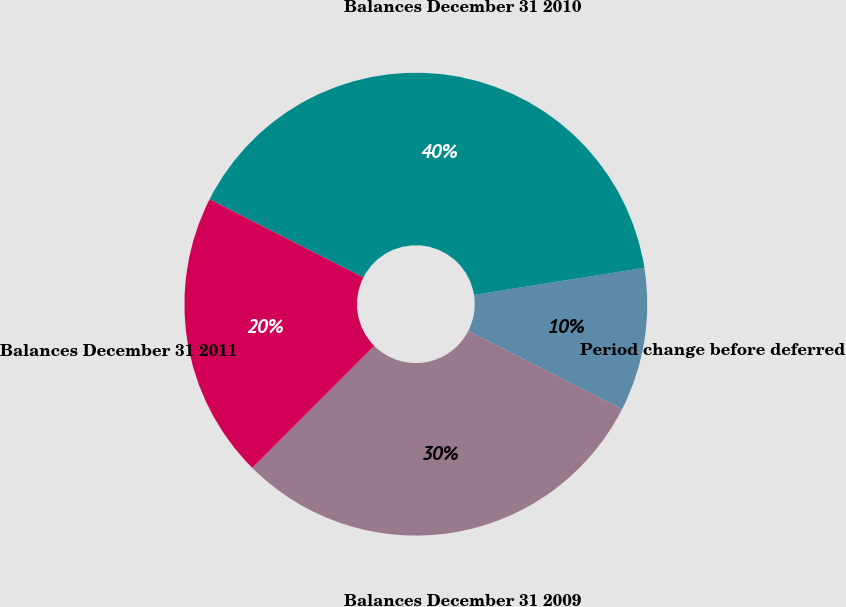Convert chart to OTSL. <chart><loc_0><loc_0><loc_500><loc_500><pie_chart><fcel>Balances December 31 2009<fcel>Period change before deferred<fcel>Balances December 31 2010<fcel>Balances December 31 2011<nl><fcel>30.0%<fcel>10.0%<fcel>40.0%<fcel>20.0%<nl></chart> 